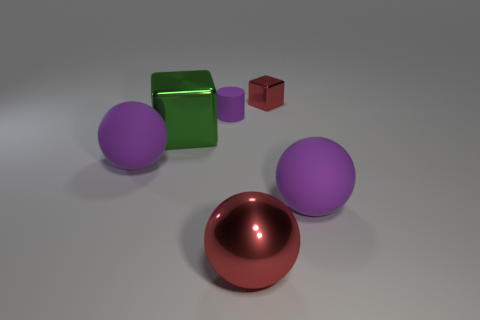Add 2 big red objects. How many objects exist? 8 Subtract all blocks. How many objects are left? 4 Add 1 cubes. How many cubes are left? 3 Add 2 large metallic balls. How many large metallic balls exist? 3 Subtract 0 gray spheres. How many objects are left? 6 Subtract all green blocks. Subtract all purple rubber cylinders. How many objects are left? 4 